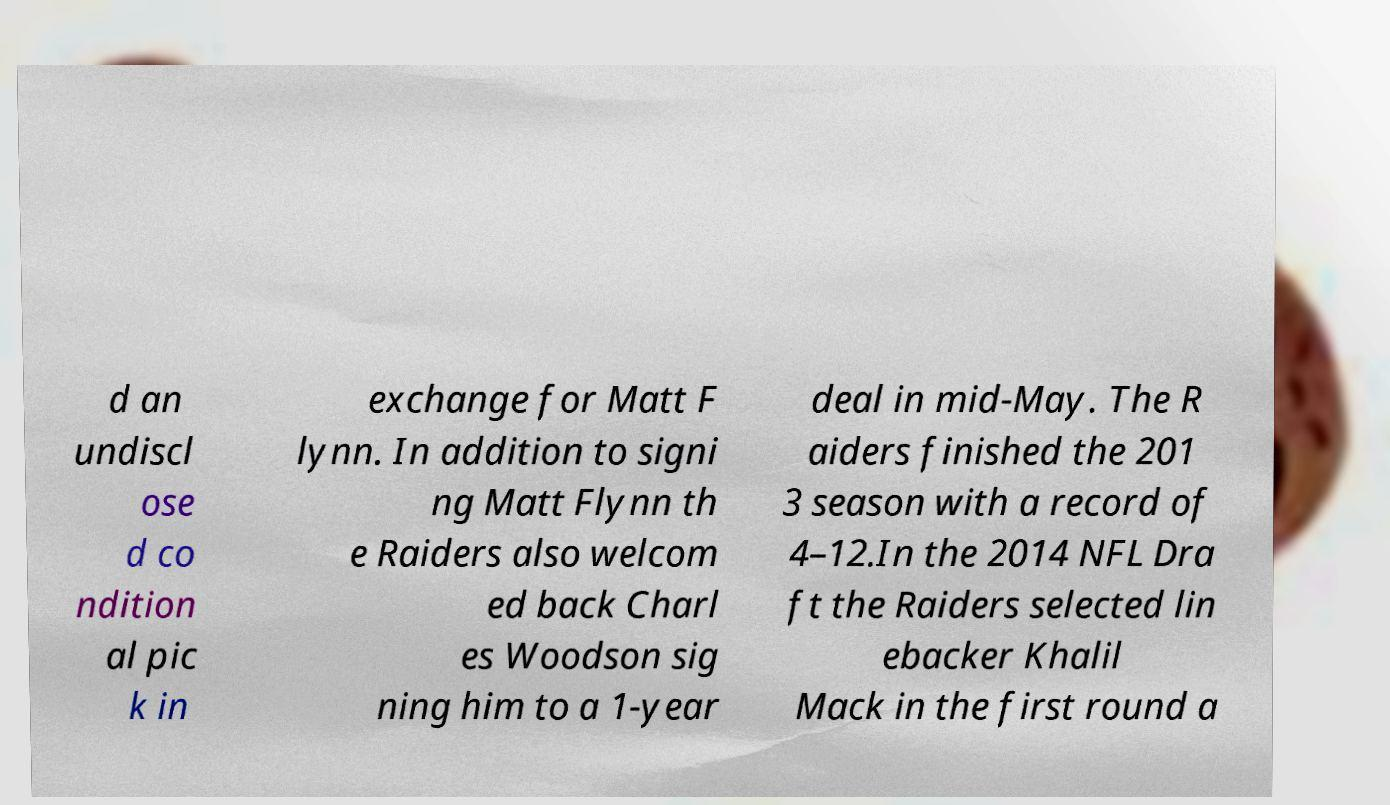What messages or text are displayed in this image? I need them in a readable, typed format. d an undiscl ose d co ndition al pic k in exchange for Matt F lynn. In addition to signi ng Matt Flynn th e Raiders also welcom ed back Charl es Woodson sig ning him to a 1-year deal in mid-May. The R aiders finished the 201 3 season with a record of 4–12.In the 2014 NFL Dra ft the Raiders selected lin ebacker Khalil Mack in the first round a 